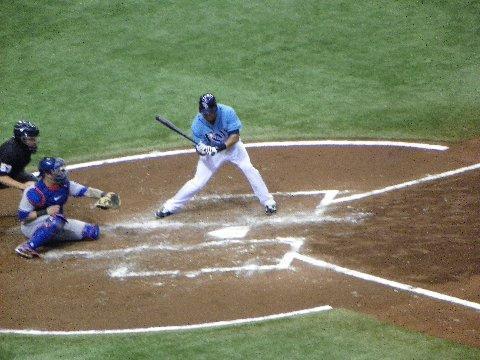How many people are there?
Give a very brief answer. 2. How many benches are on the left of the room?
Give a very brief answer. 0. 